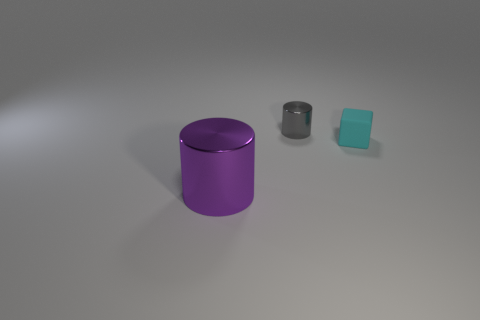What is the material texture of the objects? The large cylinder exhibits a smooth, polished surface, indicative of a reflective material such as plastic or metal. The smaller cylinder has a matte finish suggesting it might be made of metal, while the cube seems to have a slightly textured face, likely a different type of plastic. 